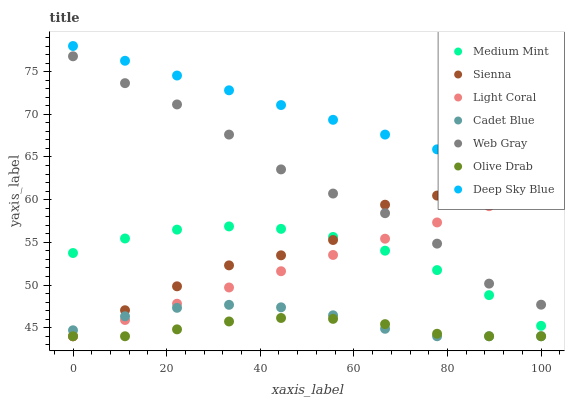Does Olive Drab have the minimum area under the curve?
Answer yes or no. Yes. Does Deep Sky Blue have the maximum area under the curve?
Answer yes or no. Yes. Does Light Coral have the minimum area under the curve?
Answer yes or no. No. Does Light Coral have the maximum area under the curve?
Answer yes or no. No. Is Deep Sky Blue the smoothest?
Answer yes or no. Yes. Is Sienna the roughest?
Answer yes or no. Yes. Is Light Coral the smoothest?
Answer yes or no. No. Is Light Coral the roughest?
Answer yes or no. No. Does Light Coral have the lowest value?
Answer yes or no. Yes. Does Web Gray have the lowest value?
Answer yes or no. No. Does Deep Sky Blue have the highest value?
Answer yes or no. Yes. Does Light Coral have the highest value?
Answer yes or no. No. Is Web Gray less than Deep Sky Blue?
Answer yes or no. Yes. Is Web Gray greater than Medium Mint?
Answer yes or no. Yes. Does Cadet Blue intersect Light Coral?
Answer yes or no. Yes. Is Cadet Blue less than Light Coral?
Answer yes or no. No. Is Cadet Blue greater than Light Coral?
Answer yes or no. No. Does Web Gray intersect Deep Sky Blue?
Answer yes or no. No. 